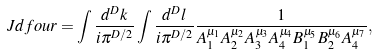Convert formula to latex. <formula><loc_0><loc_0><loc_500><loc_500>\ J d f o u r = \int \frac { d ^ { D } k } { i \pi ^ { D / 2 } } \int \frac { d ^ { D } l } { i \pi ^ { D / 2 } } \frac { 1 } { A _ { 1 } ^ { \mu _ { 1 } } A _ { 2 } ^ { \mu _ { 2 } } A _ { 3 } ^ { \mu _ { 3 } } A _ { 4 } ^ { \mu _ { 4 } } B _ { 1 } ^ { \mu _ { 5 } } B _ { 2 } ^ { \mu _ { 6 } } A _ { 4 } ^ { \mu _ { 7 } } } ,</formula> 